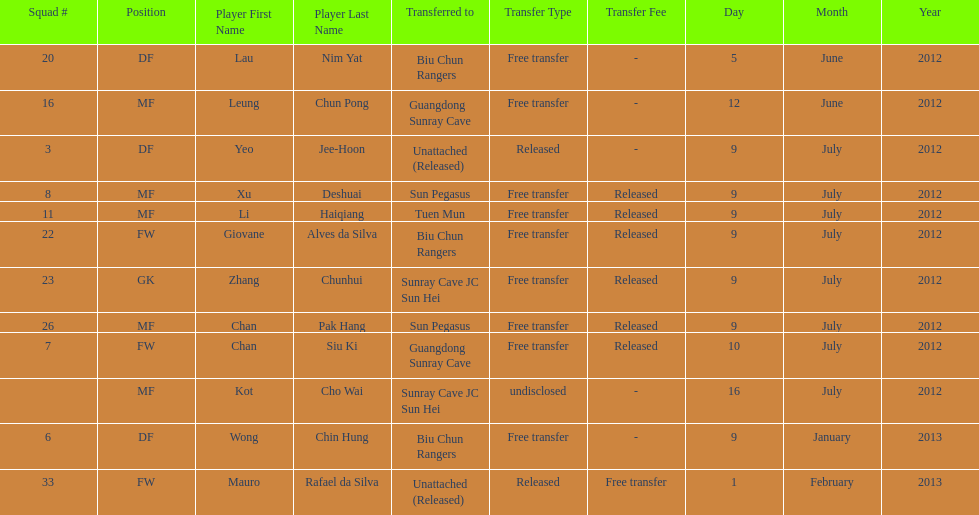How many total players were transferred to sun pegasus? 2. 